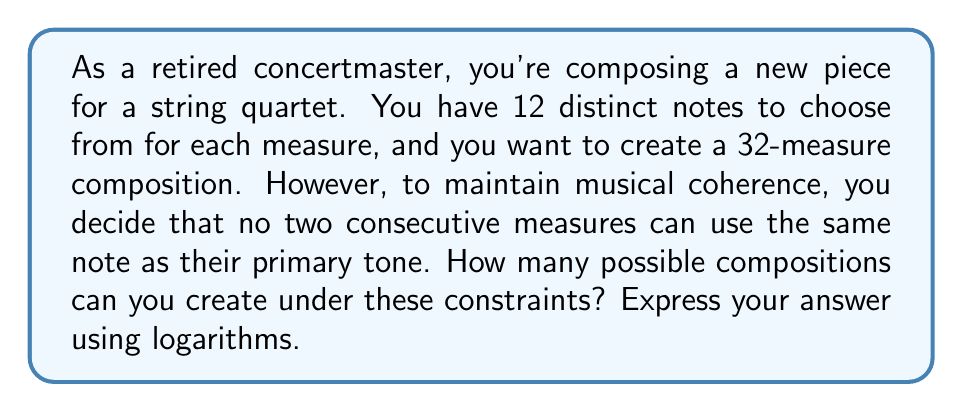Can you solve this math problem? Let's approach this step-by-step:

1) For the first measure, we have 12 choices of notes.

2) For each subsequent measure, we have 11 choices (all notes except the one used in the previous measure).

3) This pattern continues for all 32 measures.

4) The total number of possible compositions is thus:

   $12 \times 11^{31}$

5) To express this using logarithms, we can take the logarithm of both sides:

   $\log(12 \times 11^{31}) = \log(12) + 31\log(11)$

6) Using the properties of logarithms:

   $\log(12) + 31\log(11) = \log(12) + \log(11^{31})$

7) We can simplify this further:

   $\log(12 \times 11^{31}) = \log(12 \times 11^{31})$

8) Therefore, the number of possible compositions is:

   $12 \times 11^{31} = 10^{\log(12) + 31\log(11)}$

This logarithmic expression represents the exact number of possible compositions.
Answer: The number of possible compositions is $10^{\log(12) + 31\log(11)}$. 